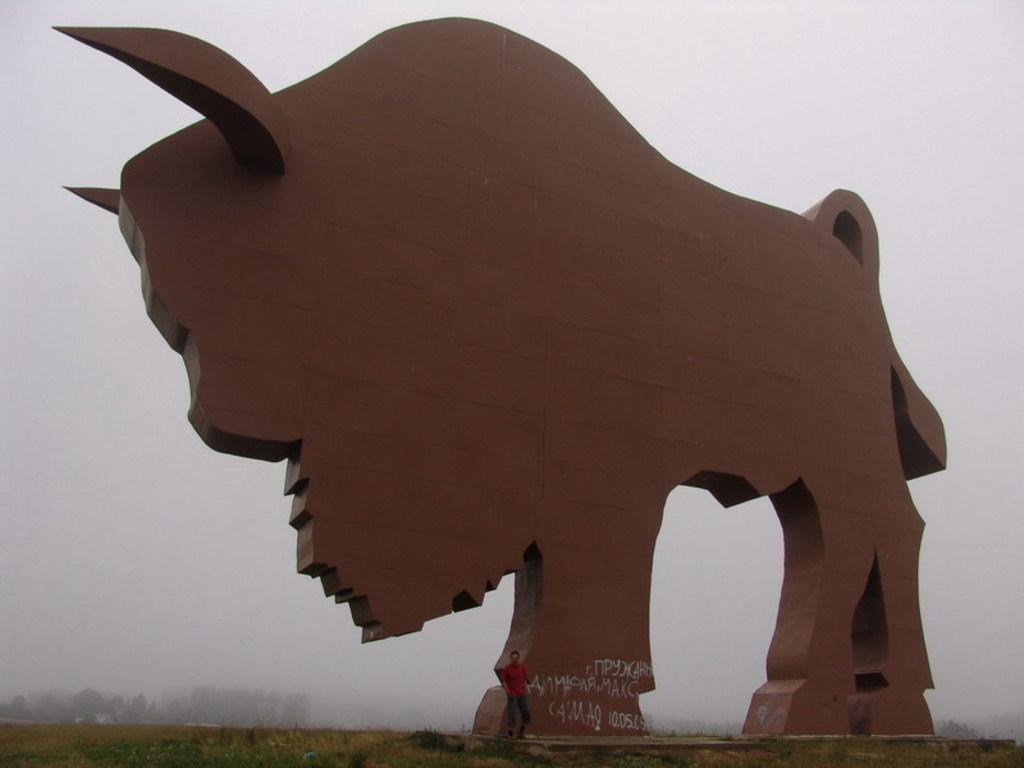Could you give a brief overview of what you see in this image? At the bottom of the picture we can see shrubs, grass and a person. In the middle of the picture there is a sculpture of a bull. In the background there are trees. At the top we can see fog. 